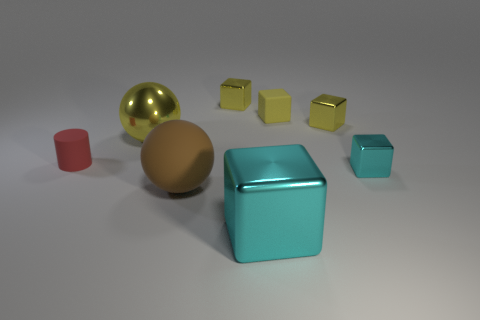Subtract all cyan blocks. How many blocks are left? 3 How many yellow blocks must be subtracted to get 1 yellow blocks? 2 Subtract all cylinders. How many objects are left? 7 Subtract 4 cubes. How many cubes are left? 1 Subtract all cyan cubes. How many cubes are left? 3 Subtract 0 cyan spheres. How many objects are left? 8 Subtract all green balls. Subtract all yellow blocks. How many balls are left? 2 Subtract all red spheres. How many blue cylinders are left? 0 Subtract all large cyan shiny cubes. Subtract all large metallic objects. How many objects are left? 5 Add 1 yellow metal cubes. How many yellow metal cubes are left? 3 